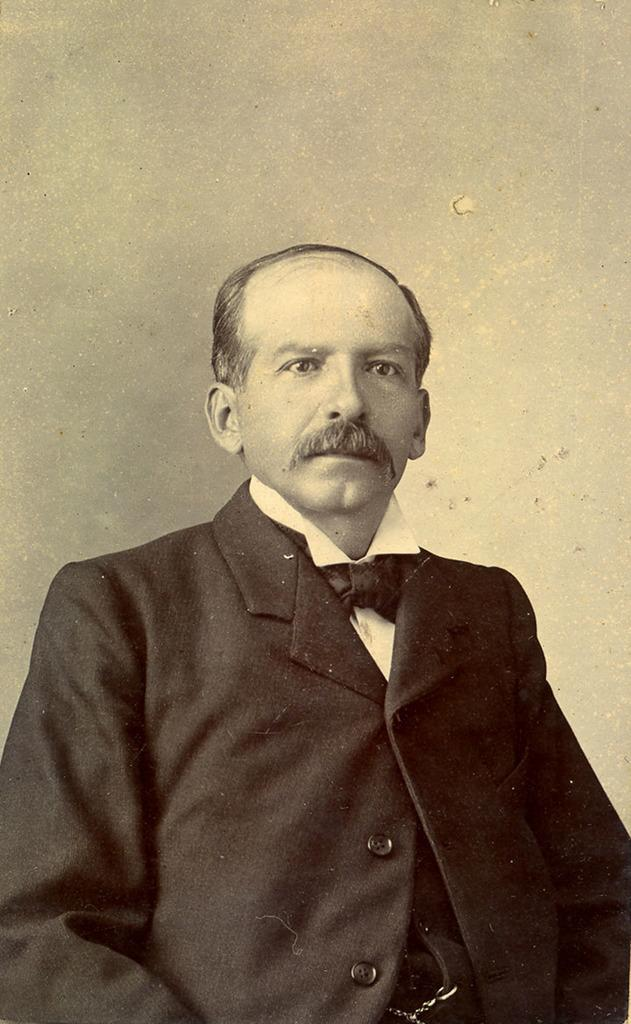Who is the main subject in the image? There is an old man in the image. What is the old man wearing? The old man is wearing a suit. What can be seen in the background of the image? There is a wall in the background of the image. What type of rose is the old man holding in the image? There is no rose present in the image; the old man is not holding anything. 